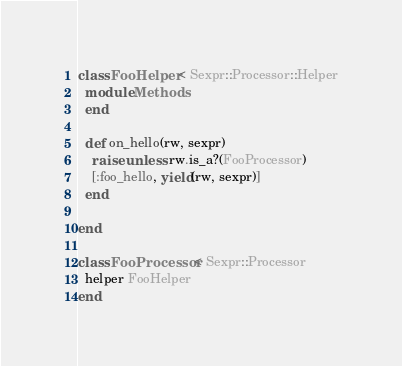Convert code to text. <code><loc_0><loc_0><loc_500><loc_500><_Ruby_>class FooHelper < Sexpr::Processor::Helper
  module Methods
  end

  def on_hello(rw, sexpr)
    raise unless rw.is_a?(FooProcessor)
    [:foo_hello, yield(rw, sexpr)]
  end

end

class FooProcessor < Sexpr::Processor
  helper FooHelper
end</code> 